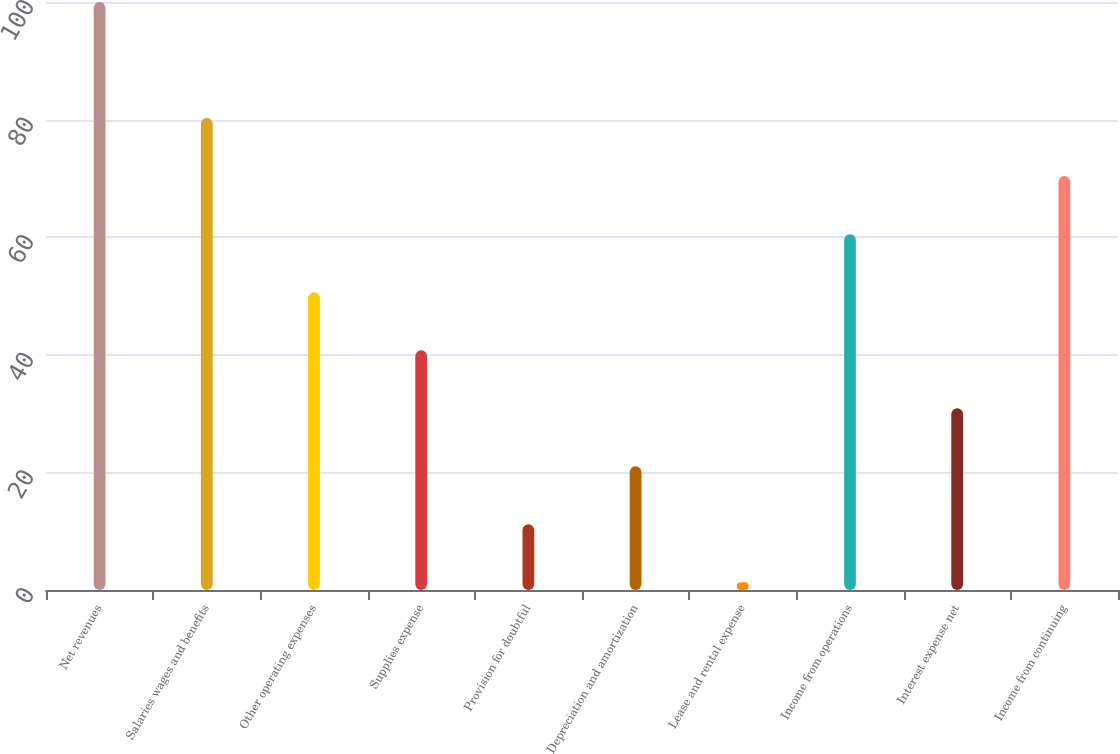Convert chart. <chart><loc_0><loc_0><loc_500><loc_500><bar_chart><fcel>Net revenues<fcel>Salaries wages and benefits<fcel>Other operating expenses<fcel>Supplies expense<fcel>Provision for doubtful<fcel>Depreciation and amortization<fcel>Lease and rental expense<fcel>Income from operations<fcel>Interest expense net<fcel>Income from continuing<nl><fcel>100<fcel>80.26<fcel>50.65<fcel>40.78<fcel>11.17<fcel>21.04<fcel>1.3<fcel>60.52<fcel>30.91<fcel>70.39<nl></chart> 